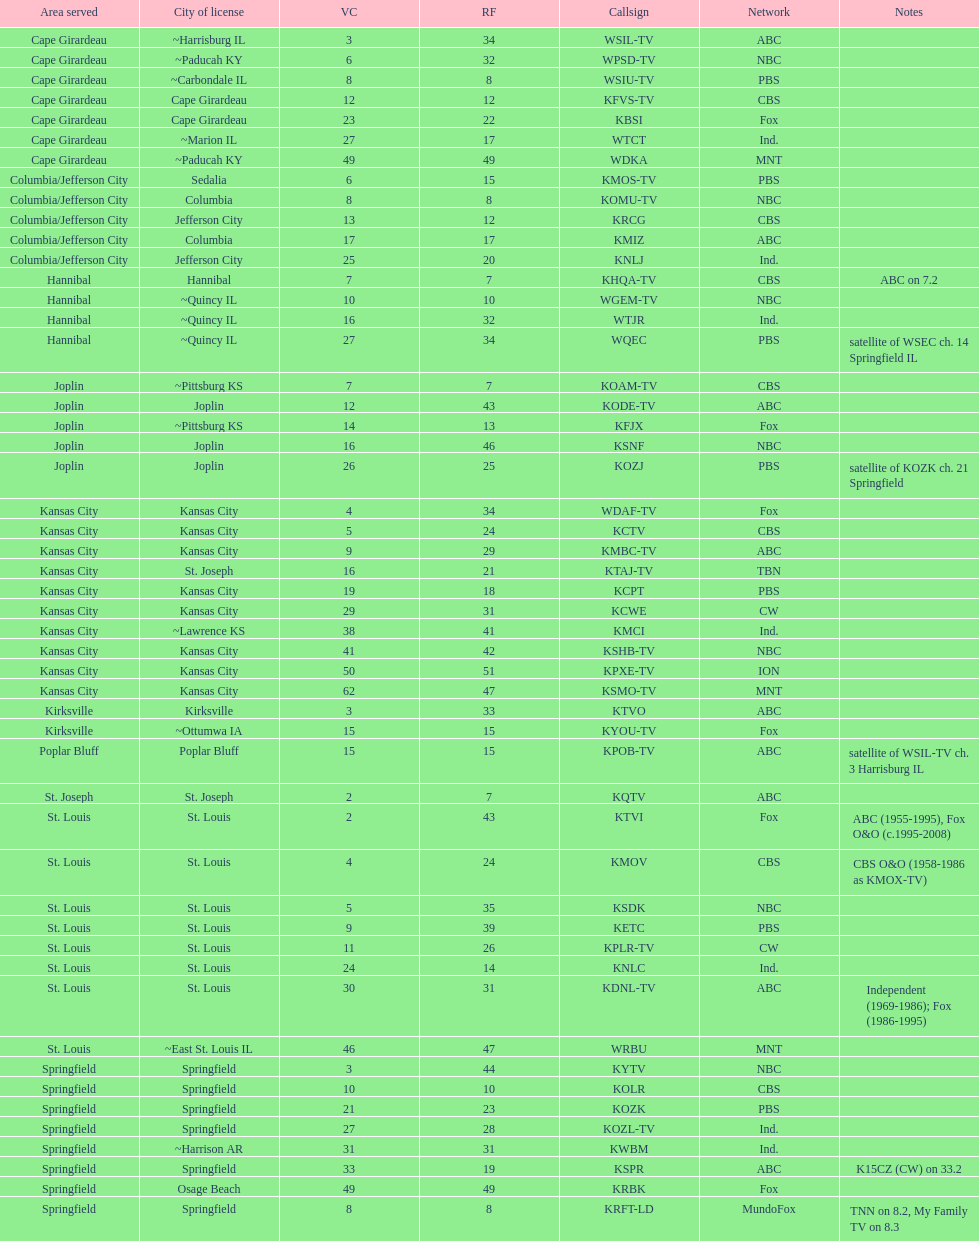Kode-tv and wsil-tv both are a part of which network? ABC. Help me parse the entirety of this table. {'header': ['Area served', 'City of license', 'VC', 'RF', 'Callsign', 'Network', 'Notes'], 'rows': [['Cape Girardeau', '~Harrisburg IL', '3', '34', 'WSIL-TV', 'ABC', ''], ['Cape Girardeau', '~Paducah KY', '6', '32', 'WPSD-TV', 'NBC', ''], ['Cape Girardeau', '~Carbondale IL', '8', '8', 'WSIU-TV', 'PBS', ''], ['Cape Girardeau', 'Cape Girardeau', '12', '12', 'KFVS-TV', 'CBS', ''], ['Cape Girardeau', 'Cape Girardeau', '23', '22', 'KBSI', 'Fox', ''], ['Cape Girardeau', '~Marion IL', '27', '17', 'WTCT', 'Ind.', ''], ['Cape Girardeau', '~Paducah KY', '49', '49', 'WDKA', 'MNT', ''], ['Columbia/Jefferson City', 'Sedalia', '6', '15', 'KMOS-TV', 'PBS', ''], ['Columbia/Jefferson City', 'Columbia', '8', '8', 'KOMU-TV', 'NBC', ''], ['Columbia/Jefferson City', 'Jefferson City', '13', '12', 'KRCG', 'CBS', ''], ['Columbia/Jefferson City', 'Columbia', '17', '17', 'KMIZ', 'ABC', ''], ['Columbia/Jefferson City', 'Jefferson City', '25', '20', 'KNLJ', 'Ind.', ''], ['Hannibal', 'Hannibal', '7', '7', 'KHQA-TV', 'CBS', 'ABC on 7.2'], ['Hannibal', '~Quincy IL', '10', '10', 'WGEM-TV', 'NBC', ''], ['Hannibal', '~Quincy IL', '16', '32', 'WTJR', 'Ind.', ''], ['Hannibal', '~Quincy IL', '27', '34', 'WQEC', 'PBS', 'satellite of WSEC ch. 14 Springfield IL'], ['Joplin', '~Pittsburg KS', '7', '7', 'KOAM-TV', 'CBS', ''], ['Joplin', 'Joplin', '12', '43', 'KODE-TV', 'ABC', ''], ['Joplin', '~Pittsburg KS', '14', '13', 'KFJX', 'Fox', ''], ['Joplin', 'Joplin', '16', '46', 'KSNF', 'NBC', ''], ['Joplin', 'Joplin', '26', '25', 'KOZJ', 'PBS', 'satellite of KOZK ch. 21 Springfield'], ['Kansas City', 'Kansas City', '4', '34', 'WDAF-TV', 'Fox', ''], ['Kansas City', 'Kansas City', '5', '24', 'KCTV', 'CBS', ''], ['Kansas City', 'Kansas City', '9', '29', 'KMBC-TV', 'ABC', ''], ['Kansas City', 'St. Joseph', '16', '21', 'KTAJ-TV', 'TBN', ''], ['Kansas City', 'Kansas City', '19', '18', 'KCPT', 'PBS', ''], ['Kansas City', 'Kansas City', '29', '31', 'KCWE', 'CW', ''], ['Kansas City', '~Lawrence KS', '38', '41', 'KMCI', 'Ind.', ''], ['Kansas City', 'Kansas City', '41', '42', 'KSHB-TV', 'NBC', ''], ['Kansas City', 'Kansas City', '50', '51', 'KPXE-TV', 'ION', ''], ['Kansas City', 'Kansas City', '62', '47', 'KSMO-TV', 'MNT', ''], ['Kirksville', 'Kirksville', '3', '33', 'KTVO', 'ABC', ''], ['Kirksville', '~Ottumwa IA', '15', '15', 'KYOU-TV', 'Fox', ''], ['Poplar Bluff', 'Poplar Bluff', '15', '15', 'KPOB-TV', 'ABC', 'satellite of WSIL-TV ch. 3 Harrisburg IL'], ['St. Joseph', 'St. Joseph', '2', '7', 'KQTV', 'ABC', ''], ['St. Louis', 'St. Louis', '2', '43', 'KTVI', 'Fox', 'ABC (1955-1995), Fox O&O (c.1995-2008)'], ['St. Louis', 'St. Louis', '4', '24', 'KMOV', 'CBS', 'CBS O&O (1958-1986 as KMOX-TV)'], ['St. Louis', 'St. Louis', '5', '35', 'KSDK', 'NBC', ''], ['St. Louis', 'St. Louis', '9', '39', 'KETC', 'PBS', ''], ['St. Louis', 'St. Louis', '11', '26', 'KPLR-TV', 'CW', ''], ['St. Louis', 'St. Louis', '24', '14', 'KNLC', 'Ind.', ''], ['St. Louis', 'St. Louis', '30', '31', 'KDNL-TV', 'ABC', 'Independent (1969-1986); Fox (1986-1995)'], ['St. Louis', '~East St. Louis IL', '46', '47', 'WRBU', 'MNT', ''], ['Springfield', 'Springfield', '3', '44', 'KYTV', 'NBC', ''], ['Springfield', 'Springfield', '10', '10', 'KOLR', 'CBS', ''], ['Springfield', 'Springfield', '21', '23', 'KOZK', 'PBS', ''], ['Springfield', 'Springfield', '27', '28', 'KOZL-TV', 'Ind.', ''], ['Springfield', '~Harrison AR', '31', '31', 'KWBM', 'Ind.', ''], ['Springfield', 'Springfield', '33', '19', 'KSPR', 'ABC', 'K15CZ (CW) on 33.2'], ['Springfield', 'Osage Beach', '49', '49', 'KRBK', 'Fox', ''], ['Springfield', 'Springfield', '8', '8', 'KRFT-LD', 'MundoFox', 'TNN on 8.2, My Family TV on 8.3']]} 